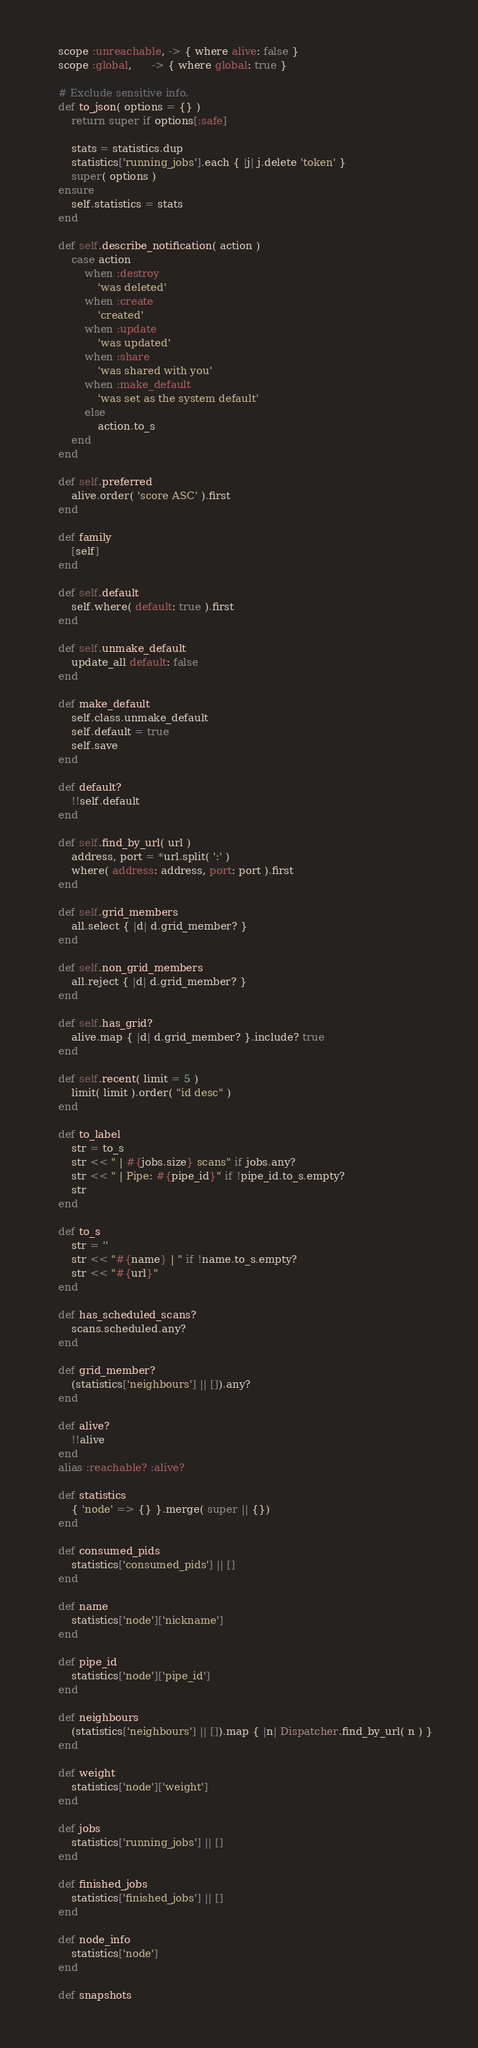Convert code to text. <code><loc_0><loc_0><loc_500><loc_500><_Ruby_>    scope :unreachable, -> { where alive: false }
    scope :global,      -> { where global: true }

    # Exclude sensitive info.
    def to_json( options = {} )
        return super if options[:safe]

        stats = statistics.dup
        statistics['running_jobs'].each { |j| j.delete 'token' }
        super( options )
    ensure
        self.statistics = stats
    end

    def self.describe_notification( action )
        case action
            when :destroy
                'was deleted'
            when :create
                'created'
            when :update
                'was updated'
            when :share
                'was shared with you'
            when :make_default
                'was set as the system default'
            else
                action.to_s
        end
    end

    def self.preferred
        alive.order( 'score ASC' ).first
    end

    def family
        [self]
    end

    def self.default
        self.where( default: true ).first
    end

    def self.unmake_default
        update_all default: false
    end

    def make_default
        self.class.unmake_default
        self.default = true
        self.save
    end

    def default?
        !!self.default
    end

    def self.find_by_url( url )
        address, port = *url.split( ':' )
        where( address: address, port: port ).first
    end

    def self.grid_members
        all.select { |d| d.grid_member? }
    end

    def self.non_grid_members
        all.reject { |d| d.grid_member? }
    end

    def self.has_grid?
        alive.map { |d| d.grid_member? }.include? true
    end

    def self.recent( limit = 5 )
        limit( limit ).order( "id desc" )
    end

    def to_label
        str = to_s
        str << " | #{jobs.size} scans" if jobs.any?
        str << " | Pipe: #{pipe_id}" if !pipe_id.to_s.empty?
        str
    end

    def to_s
        str = ''
        str << "#{name} | " if !name.to_s.empty?
        str << "#{url}"
    end

    def has_scheduled_scans?
        scans.scheduled.any?
    end

    def grid_member?
        (statistics['neighbours'] || []).any?
    end

    def alive?
        !!alive
    end
    alias :reachable? :alive?

    def statistics
        { 'node' => {} }.merge( super || {})
    end

    def consumed_pids
        statistics['consumed_pids'] || []
    end

    def name
        statistics['node']['nickname']
    end

    def pipe_id
        statistics['node']['pipe_id']
    end

    def neighbours
        (statistics['neighbours'] || []).map { |n| Dispatcher.find_by_url( n ) }
    end

    def weight
        statistics['node']['weight']
    end

    def jobs
        statistics['running_jobs'] || []
    end

    def finished_jobs
        statistics['finished_jobs'] || []
    end

    def node_info
        statistics['node']
    end

    def snapshots</code> 